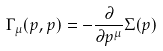<formula> <loc_0><loc_0><loc_500><loc_500>\Gamma _ { \mu } ( p , p ) = - \frac { \partial } { \partial p ^ { \mu } } \Sigma ( p )</formula> 